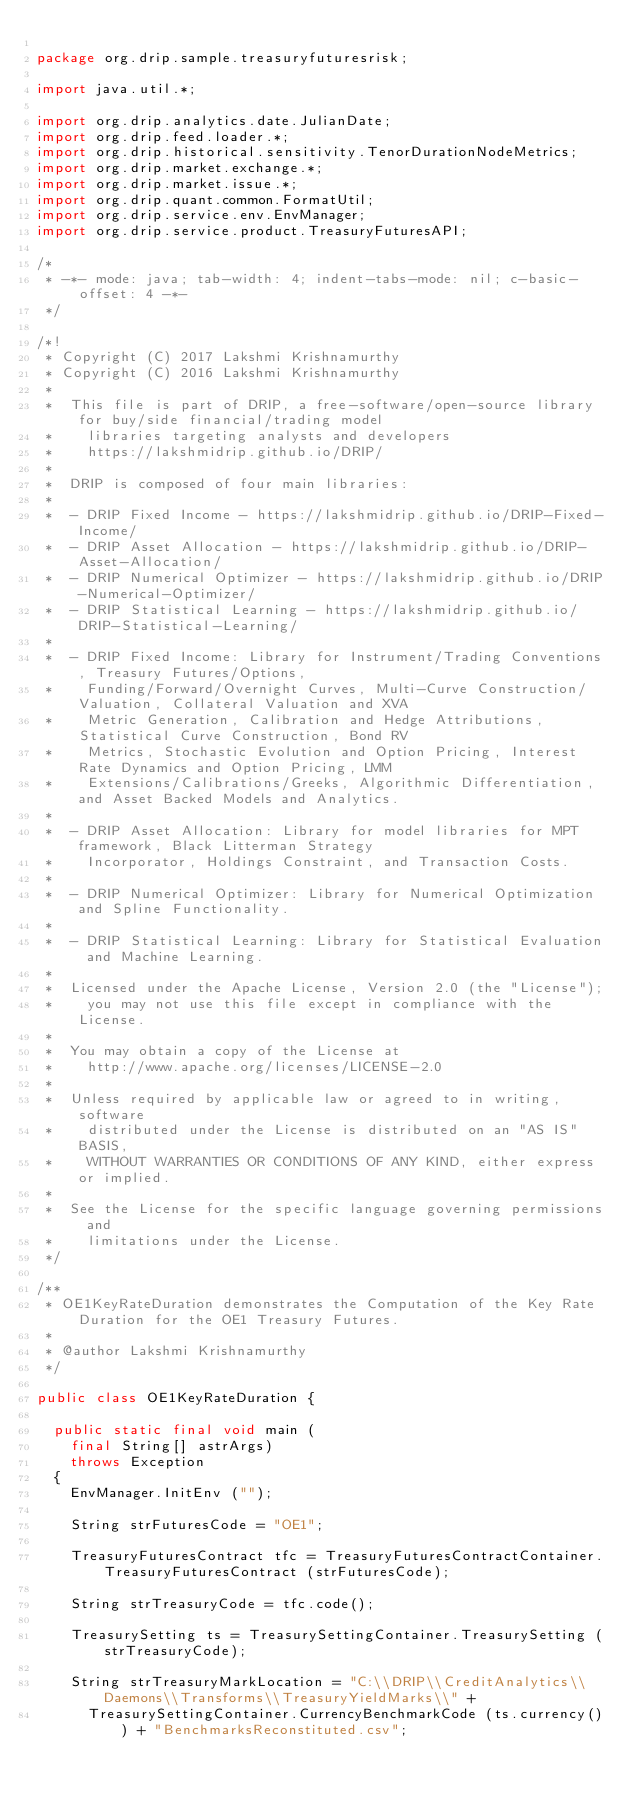<code> <loc_0><loc_0><loc_500><loc_500><_Java_>
package org.drip.sample.treasuryfuturesrisk;

import java.util.*;

import org.drip.analytics.date.JulianDate;
import org.drip.feed.loader.*;
import org.drip.historical.sensitivity.TenorDurationNodeMetrics;
import org.drip.market.exchange.*;
import org.drip.market.issue.*;
import org.drip.quant.common.FormatUtil;
import org.drip.service.env.EnvManager;
import org.drip.service.product.TreasuryFuturesAPI;

/*
 * -*- mode: java; tab-width: 4; indent-tabs-mode: nil; c-basic-offset: 4 -*-
 */

/*!
 * Copyright (C) 2017 Lakshmi Krishnamurthy
 * Copyright (C) 2016 Lakshmi Krishnamurthy
 * 
 *  This file is part of DRIP, a free-software/open-source library for buy/side financial/trading model
 *  	libraries targeting analysts and developers
 *  	https://lakshmidrip.github.io/DRIP/
 *  
 *  DRIP is composed of four main libraries:
 *  
 *  - DRIP Fixed Income - https://lakshmidrip.github.io/DRIP-Fixed-Income/
 *  - DRIP Asset Allocation - https://lakshmidrip.github.io/DRIP-Asset-Allocation/
 *  - DRIP Numerical Optimizer - https://lakshmidrip.github.io/DRIP-Numerical-Optimizer/
 *  - DRIP Statistical Learning - https://lakshmidrip.github.io/DRIP-Statistical-Learning/
 * 
 *  - DRIP Fixed Income: Library for Instrument/Trading Conventions, Treasury Futures/Options,
 *  	Funding/Forward/Overnight Curves, Multi-Curve Construction/Valuation, Collateral Valuation and XVA
 *  	Metric Generation, Calibration and Hedge Attributions, Statistical Curve Construction, Bond RV
 *  	Metrics, Stochastic Evolution and Option Pricing, Interest Rate Dynamics and Option Pricing, LMM
 *  	Extensions/Calibrations/Greeks, Algorithmic Differentiation, and Asset Backed Models and Analytics.
 * 
 *  - DRIP Asset Allocation: Library for model libraries for MPT framework, Black Litterman Strategy
 *  	Incorporator, Holdings Constraint, and Transaction Costs.
 * 
 *  - DRIP Numerical Optimizer: Library for Numerical Optimization and Spline Functionality.
 * 
 *  - DRIP Statistical Learning: Library for Statistical Evaluation and Machine Learning.
 * 
 *  Licensed under the Apache License, Version 2.0 (the "License");
 *   	you may not use this file except in compliance with the License.
 *   
 *  You may obtain a copy of the License at
 *  	http://www.apache.org/licenses/LICENSE-2.0
 *  
 *  Unless required by applicable law or agreed to in writing, software
 *  	distributed under the License is distributed on an "AS IS" BASIS,
 *  	WITHOUT WARRANTIES OR CONDITIONS OF ANY KIND, either express or implied.
 *  
 *  See the License for the specific language governing permissions and
 *  	limitations under the License.
 */

/**
 * OE1KeyRateDuration demonstrates the Computation of the Key Rate Duration for the OE1 Treasury Futures.
 *
 * @author Lakshmi Krishnamurthy
 */

public class OE1KeyRateDuration {

	public static final void main (
		final String[] astrArgs)
		throws Exception
	{
		EnvManager.InitEnv ("");

		String strFuturesCode = "OE1";

		TreasuryFuturesContract tfc = TreasuryFuturesContractContainer.TreasuryFuturesContract (strFuturesCode);

		String strTreasuryCode = tfc.code();

		TreasurySetting ts = TreasurySettingContainer.TreasurySetting (strTreasuryCode);

		String strTreasuryMarkLocation = "C:\\DRIP\\CreditAnalytics\\Daemons\\Transforms\\TreasuryYieldMarks\\" +
			TreasurySettingContainer.CurrencyBenchmarkCode (ts.currency()) + "BenchmarksReconstituted.csv";</code> 